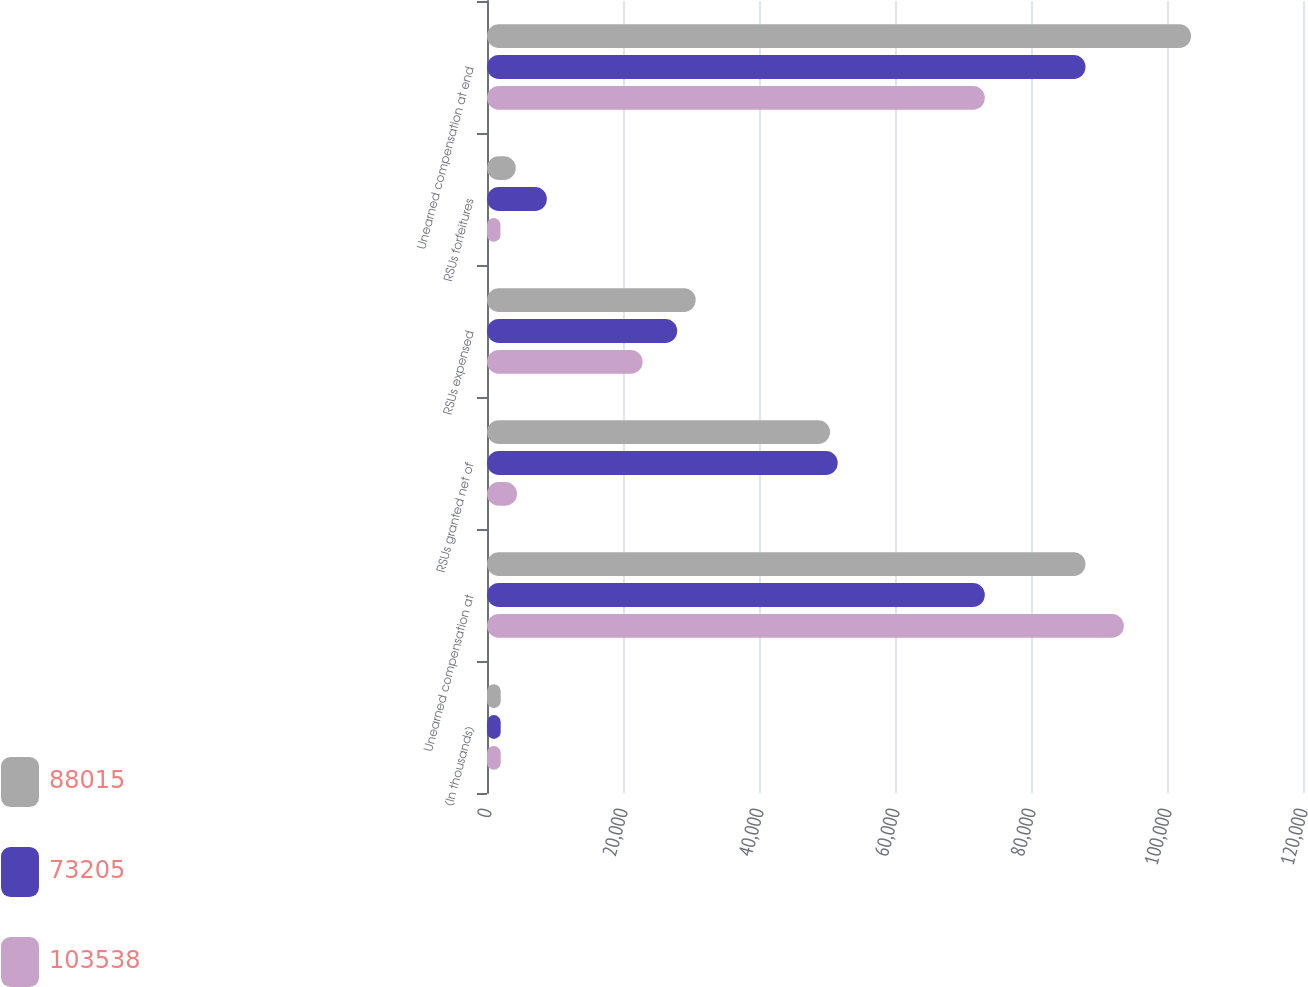Convert chart to OTSL. <chart><loc_0><loc_0><loc_500><loc_500><stacked_bar_chart><ecel><fcel>(In thousands)<fcel>Unearned compensation at<fcel>RSUs granted net of<fcel>RSUs expensed<fcel>RSUs forfeitures<fcel>Unearned compensation at end<nl><fcel>88015<fcel>2015<fcel>88015<fcel>50442<fcel>30691<fcel>4228<fcel>103538<nl><fcel>73205<fcel>2014<fcel>73205<fcel>51575<fcel>27966<fcel>8799<fcel>88015<nl><fcel>103538<fcel>2013<fcel>93653<fcel>4406<fcel>22881<fcel>1973<fcel>73205<nl></chart> 